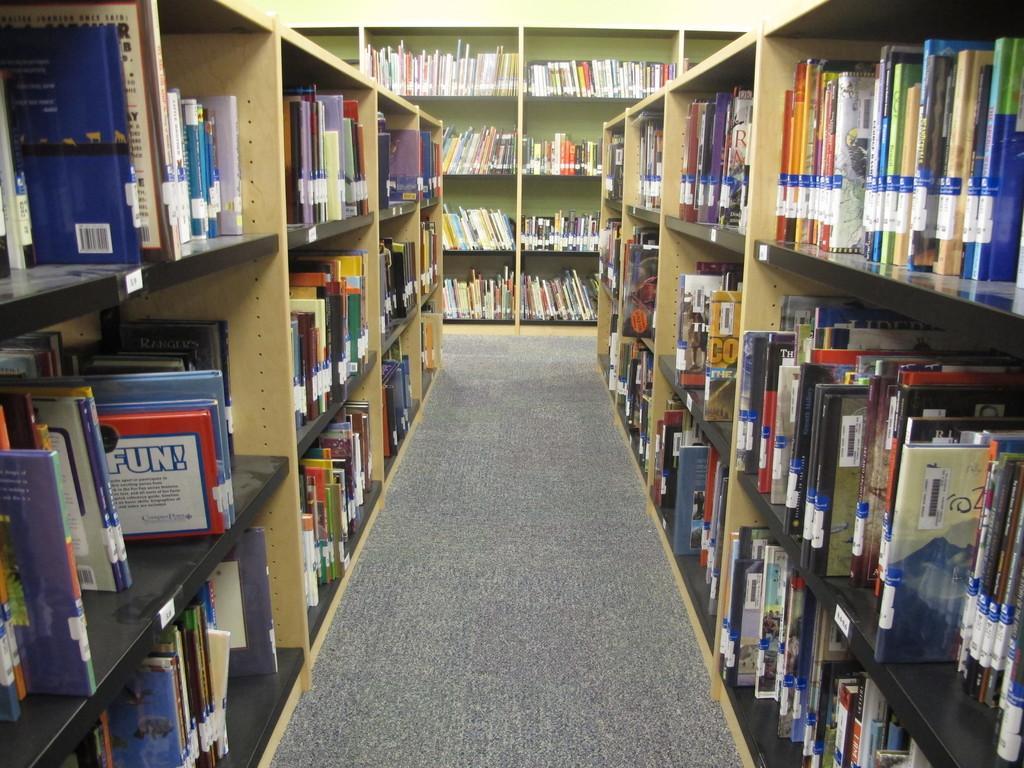Describe this image in one or two sentences. In this picture we can see the floor, books in racks and in the background we can see the wall. 